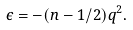<formula> <loc_0><loc_0><loc_500><loc_500>\epsilon = - ( n - 1 / 2 ) q ^ { 2 } .</formula> 